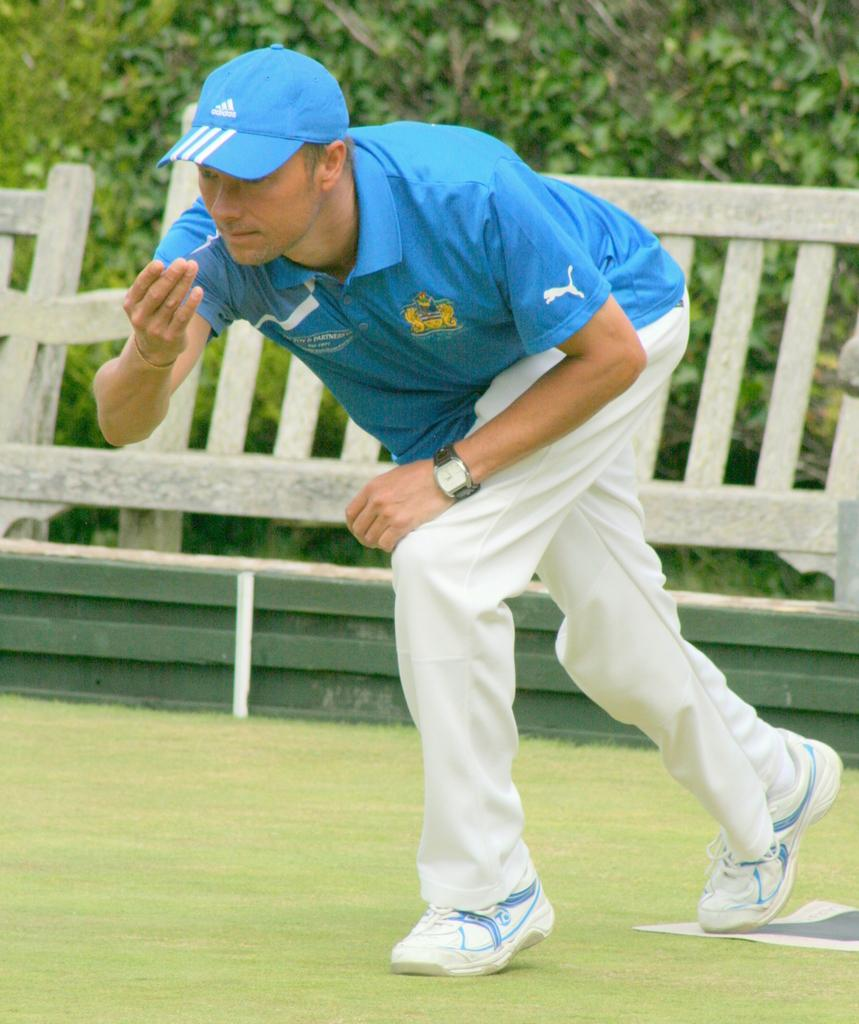Who is present in the image? There is a man in the image. What is the man wearing? The man is wearing clothes, shoes, a wristwatch, and a cap. What can be seen in the background of the image? There is grass, a fence, and leaves visible in the image. What type of beast can be seen in the image? There is no beast present in the image; it features a man and various background elements. 